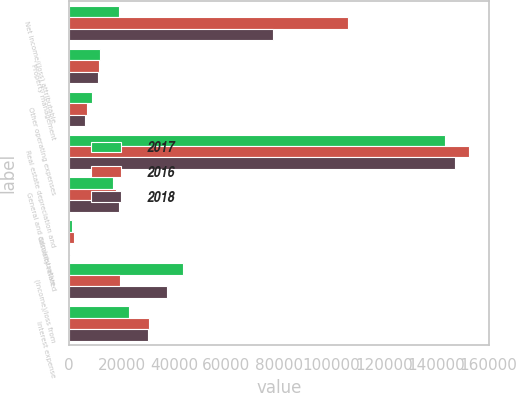Convert chart. <chart><loc_0><loc_0><loc_500><loc_500><stacked_bar_chart><ecel><fcel>Net income/(loss) attributable<fcel>Property management<fcel>Other operating expenses<fcel>Real estate depreciation and<fcel>General and administrative<fcel>Casualty-related<fcel>(Income)/loss from<fcel>Interest expense<nl><fcel>2017<fcel>18808<fcel>11878<fcel>8864<fcel>143481<fcel>16889<fcel>951<fcel>43496<fcel>22835<nl><fcel>2016<fcel>106307<fcel>11533<fcel>6833<fcel>152473<fcel>17875<fcel>1922<fcel>19256<fcel>30366<nl><fcel>2018<fcel>77818<fcel>11122<fcel>6059<fcel>147074<fcel>18808<fcel>484<fcel>37425<fcel>30067<nl></chart> 